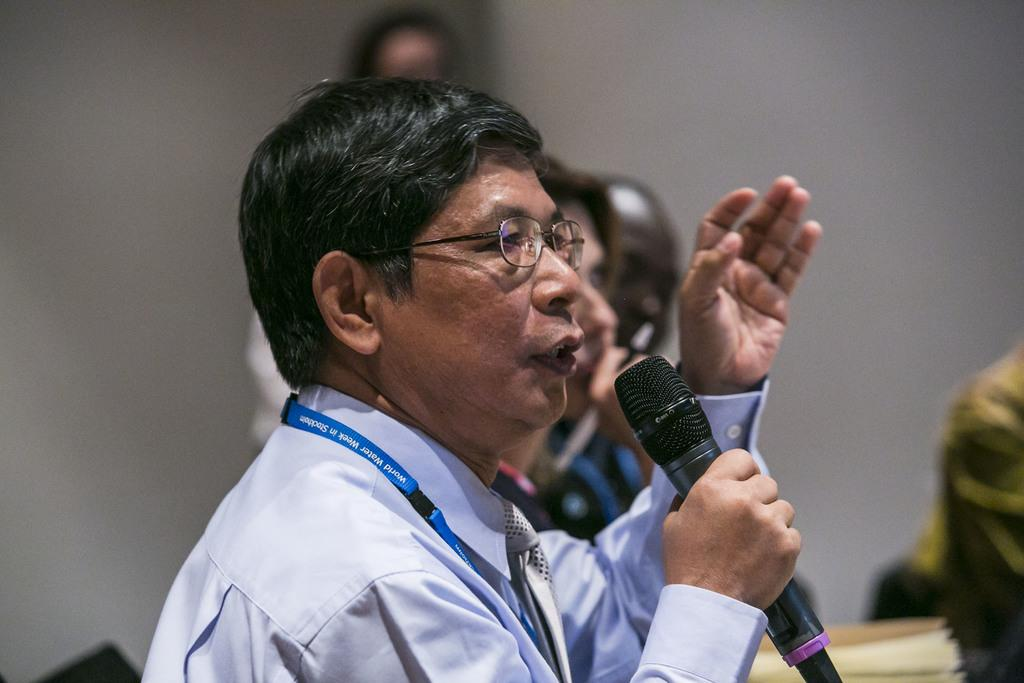What is the man in the image doing? The man is talking into a microphone. What is the man wearing in the image? The man is wearing a blue shirt. Are there any other people in the image? Yes, there are other persons in the image. What can be seen in the background of the image? There is a wall in the background of the image. Can you see a zebra in the image? No, there is no zebra present in the image. What type of reward is the man receiving for his speech in the image? There is no indication in the image that the man is receiving a reward for his speech. 